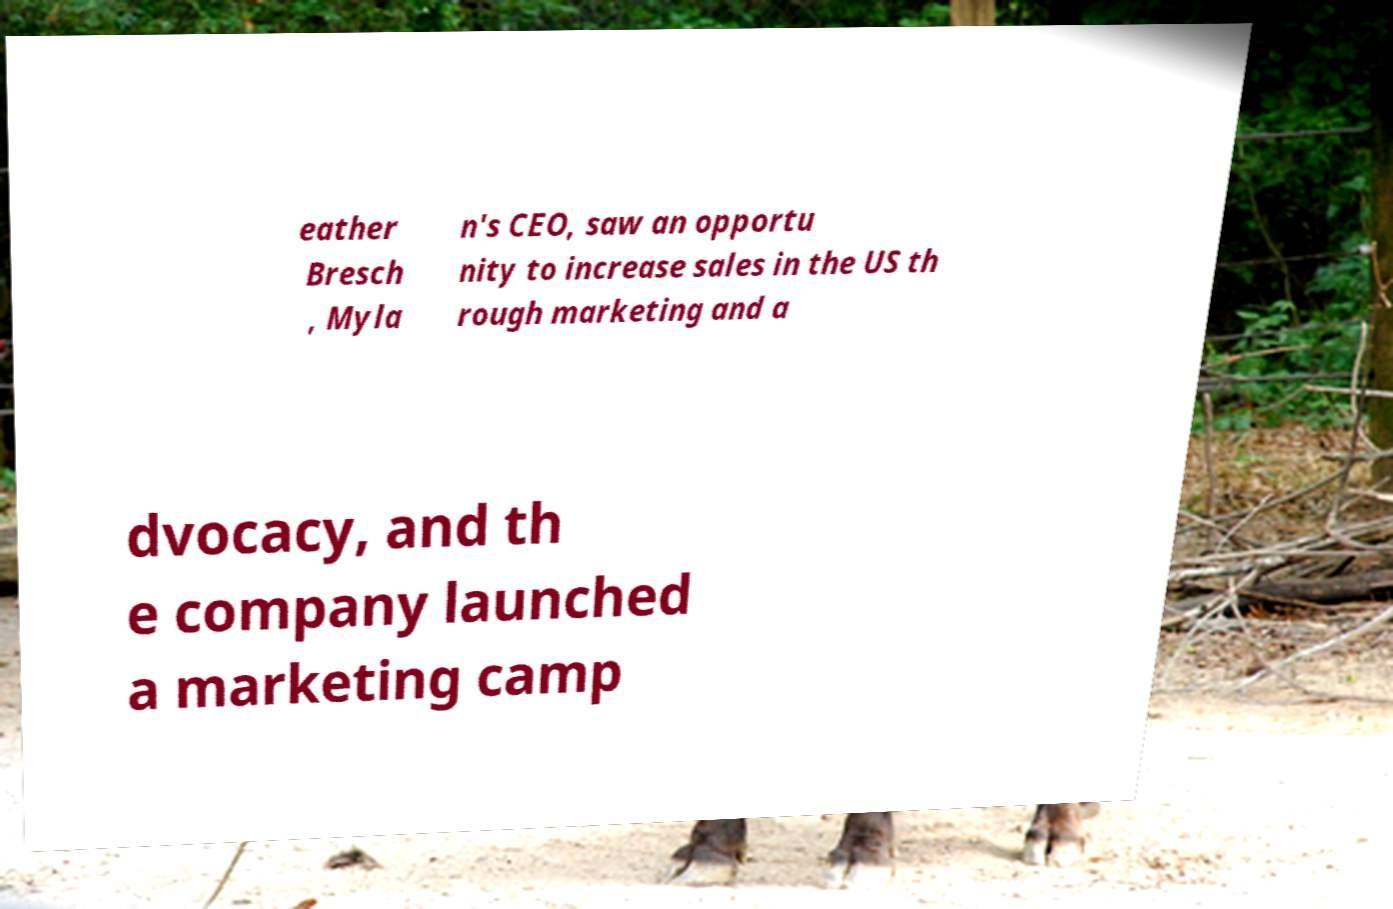Please read and relay the text visible in this image. What does it say? eather Bresch , Myla n's CEO, saw an opportu nity to increase sales in the US th rough marketing and a dvocacy, and th e company launched a marketing camp 